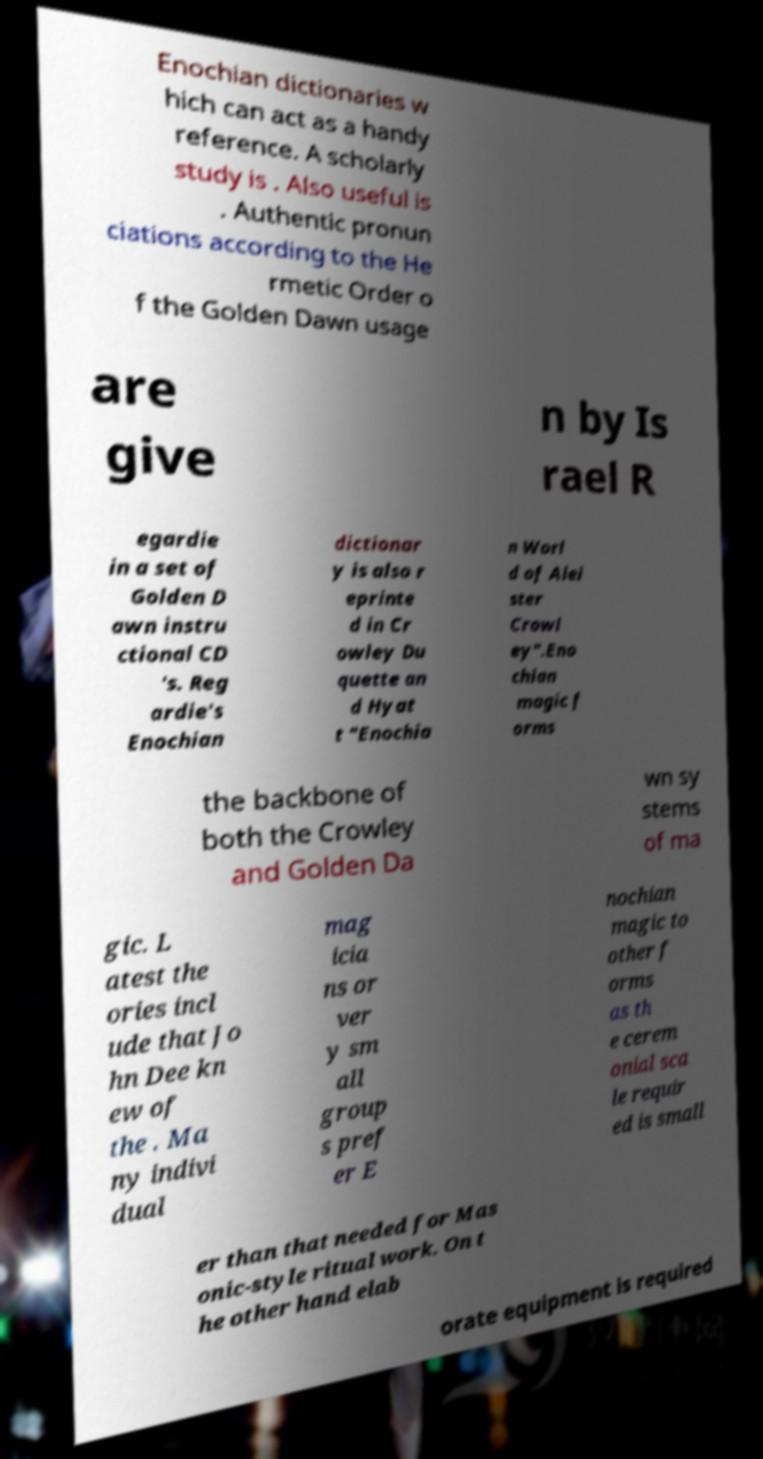For documentation purposes, I need the text within this image transcribed. Could you provide that? Enochian dictionaries w hich can act as a handy reference. A scholarly study is . Also useful is . Authentic pronun ciations according to the He rmetic Order o f the Golden Dawn usage are give n by Is rael R egardie in a set of Golden D awn instru ctional CD 's. Reg ardie's Enochian dictionar y is also r eprinte d in Cr owley Du quette an d Hyat t "Enochia n Worl d of Alei ster Crowl ey".Eno chian magic f orms the backbone of both the Crowley and Golden Da wn sy stems of ma gic. L atest the ories incl ude that Jo hn Dee kn ew of the . Ma ny indivi dual mag icia ns or ver y sm all group s pref er E nochian magic to other f orms as th e cerem onial sca le requir ed is small er than that needed for Mas onic-style ritual work. On t he other hand elab orate equipment is required 